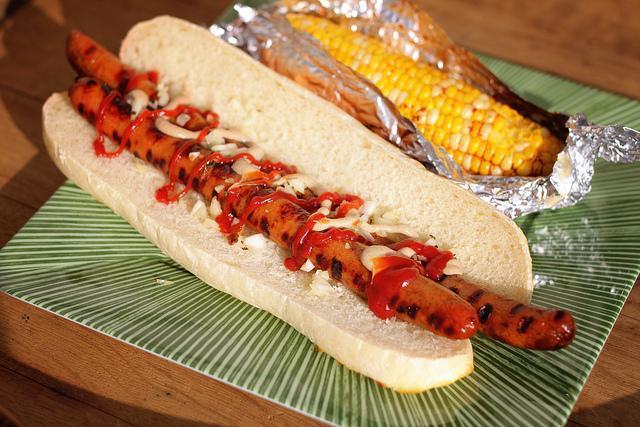How many people are wearing black tops?
Give a very brief answer. 0. 